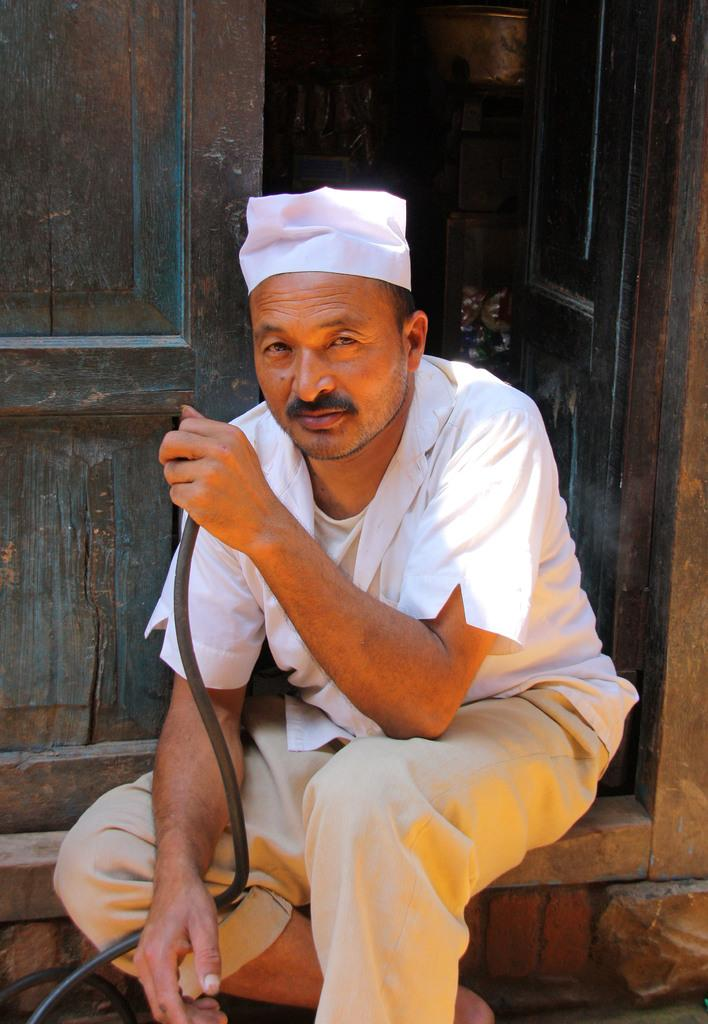What is the man in the image holding? The man is holding a hookah in the image. Where is the man sitting in the image? The man is sitting on the doorstep in the image. What is the man wearing on his head? The man is wearing a white cap in the image. What color is the man's shirt in the image? The man is wearing a white shirt in the image. What color are the man's pants in the image? The man is wearing cream pants in the image. What type of club does the man belong to in the image? There is no indication in the image that the man belongs to any club. 